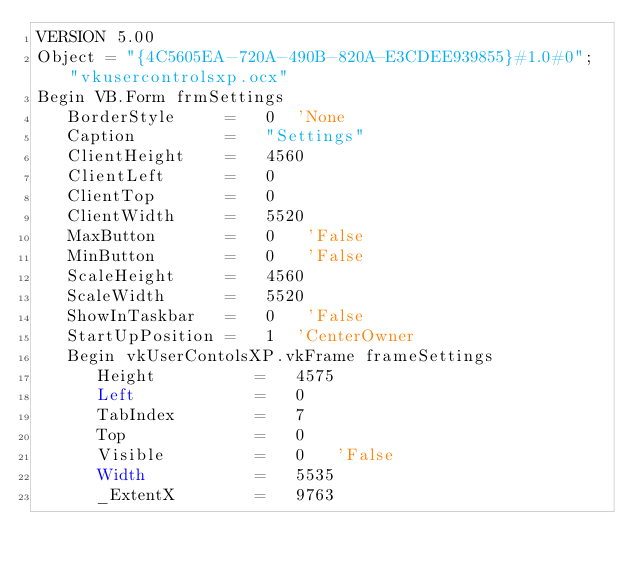<code> <loc_0><loc_0><loc_500><loc_500><_VisualBasic_>VERSION 5.00
Object = "{4C5605EA-720A-490B-820A-E3CDEE939855}#1.0#0"; "vkusercontrolsxp.ocx"
Begin VB.Form frmSettings 
   BorderStyle     =   0  'None
   Caption         =   "Settings"
   ClientHeight    =   4560
   ClientLeft      =   0
   ClientTop       =   0
   ClientWidth     =   5520
   MaxButton       =   0   'False
   MinButton       =   0   'False
   ScaleHeight     =   4560
   ScaleWidth      =   5520
   ShowInTaskbar   =   0   'False
   StartUpPosition =   1  'CenterOwner
   Begin vkUserContolsXP.vkFrame frameSettings 
      Height          =   4575
      Left            =   0
      TabIndex        =   7
      Top             =   0
      Visible         =   0   'False
      Width           =   5535
      _ExtentX        =   9763</code> 